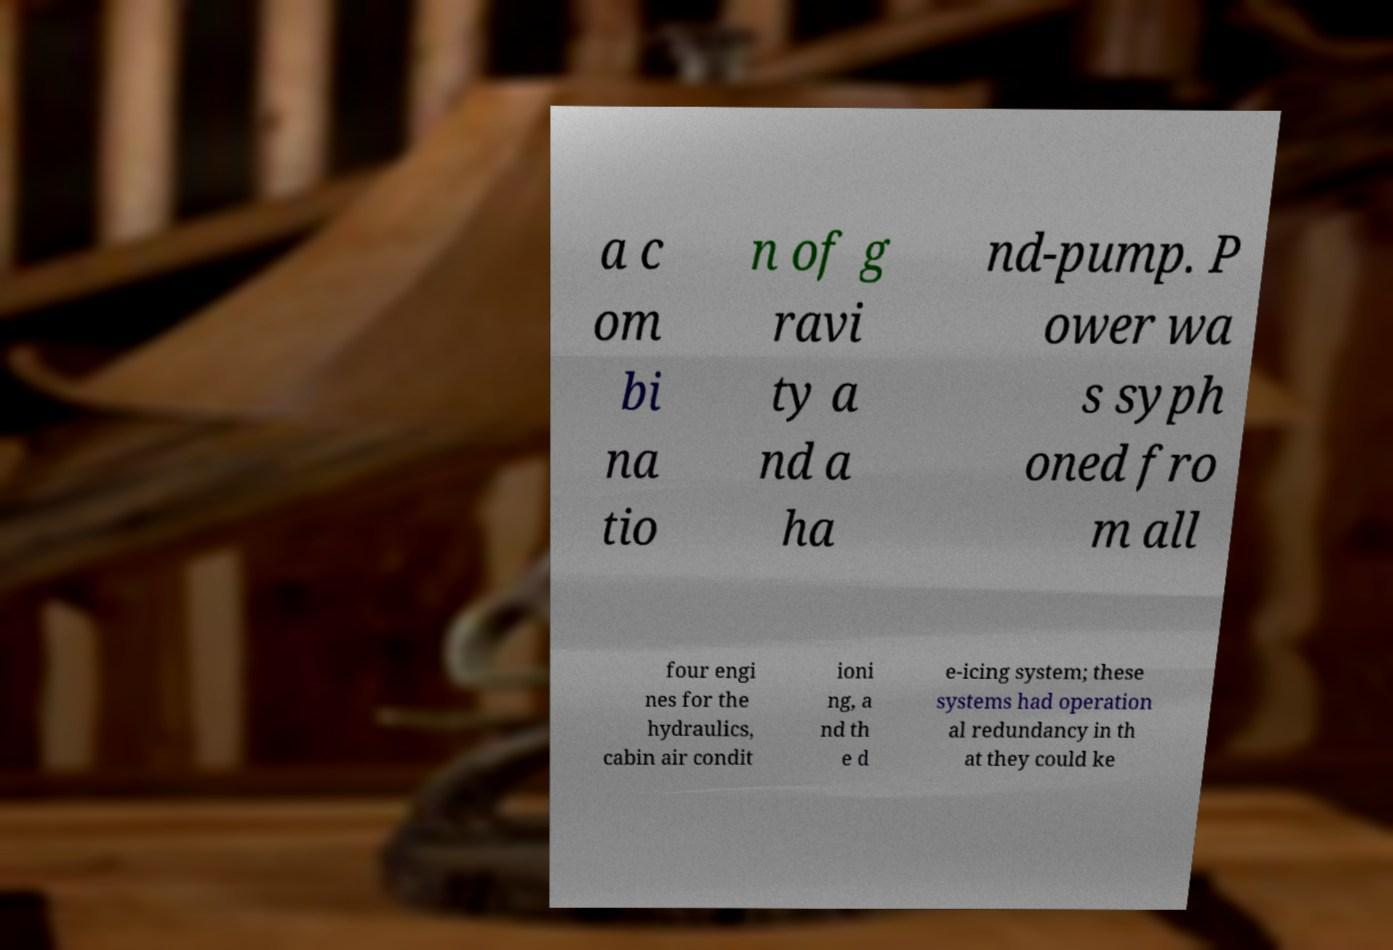Please identify and transcribe the text found in this image. a c om bi na tio n of g ravi ty a nd a ha nd-pump. P ower wa s syph oned fro m all four engi nes for the hydraulics, cabin air condit ioni ng, a nd th e d e-icing system; these systems had operation al redundancy in th at they could ke 